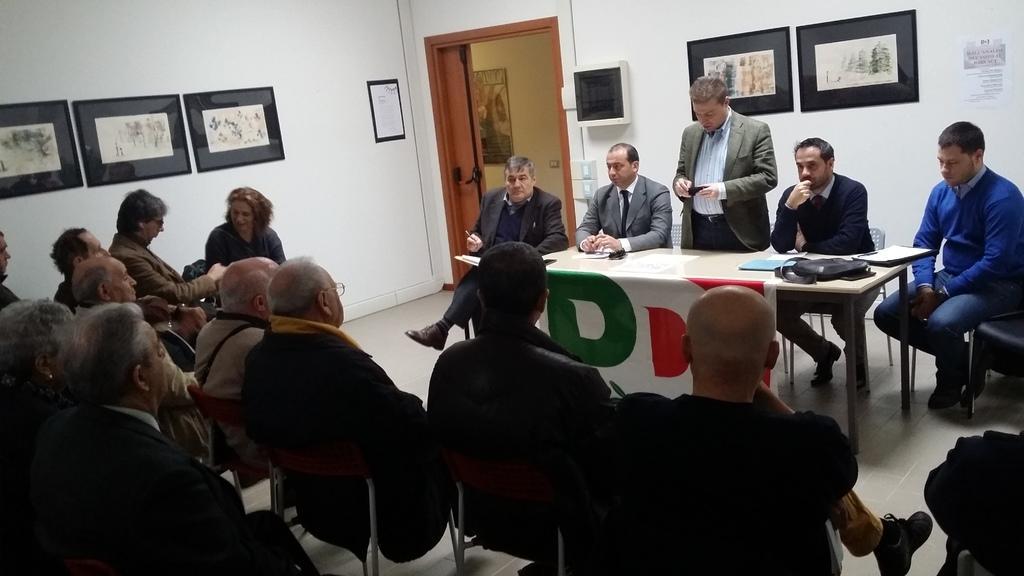In one or two sentences, can you explain what this image depicts? In this image I can see the group of people with different color dresses. I can see the table in-front of few people. On the table I can see the papers and black color objects. In the background I can see the frames to the wall. 